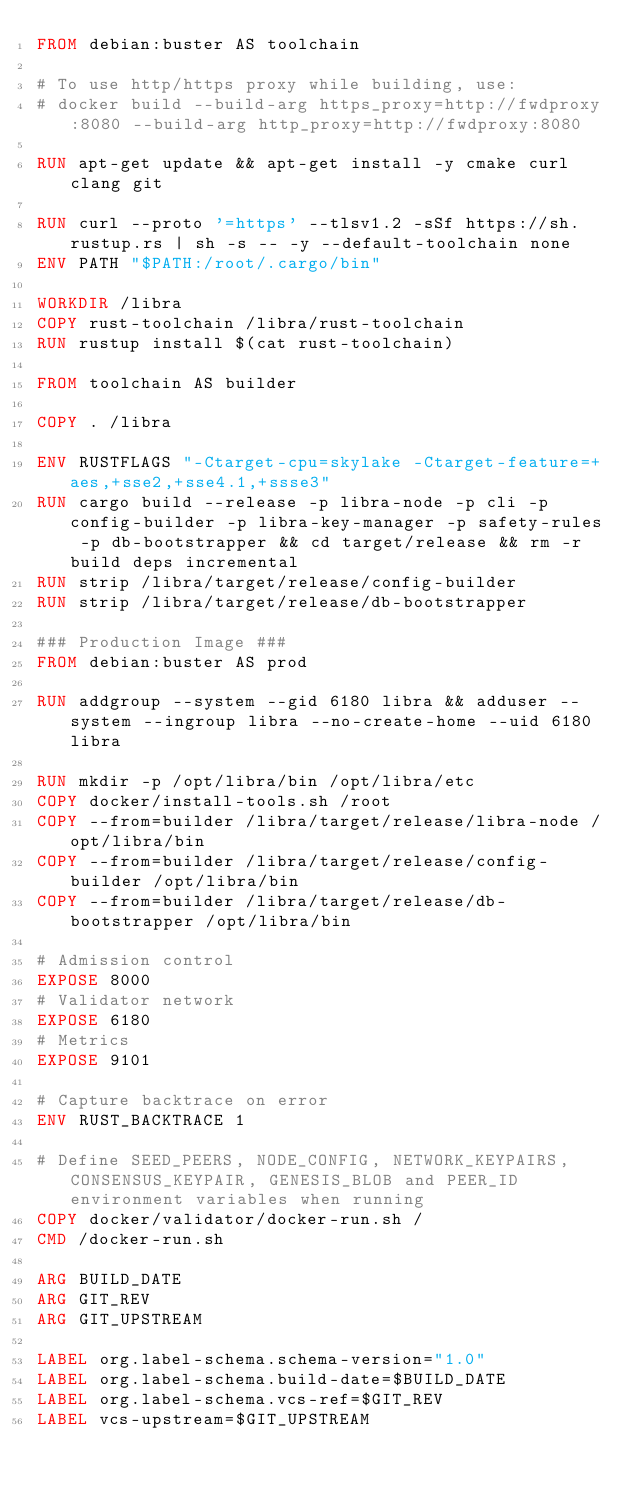<code> <loc_0><loc_0><loc_500><loc_500><_Dockerfile_>FROM debian:buster AS toolchain

# To use http/https proxy while building, use:
# docker build --build-arg https_proxy=http://fwdproxy:8080 --build-arg http_proxy=http://fwdproxy:8080

RUN apt-get update && apt-get install -y cmake curl clang git

RUN curl --proto '=https' --tlsv1.2 -sSf https://sh.rustup.rs | sh -s -- -y --default-toolchain none
ENV PATH "$PATH:/root/.cargo/bin"

WORKDIR /libra
COPY rust-toolchain /libra/rust-toolchain
RUN rustup install $(cat rust-toolchain)

FROM toolchain AS builder

COPY . /libra

ENV RUSTFLAGS "-Ctarget-cpu=skylake -Ctarget-feature=+aes,+sse2,+sse4.1,+ssse3"
RUN cargo build --release -p libra-node -p cli -p config-builder -p libra-key-manager -p safety-rules -p db-bootstrapper && cd target/release && rm -r build deps incremental
RUN strip /libra/target/release/config-builder
RUN strip /libra/target/release/db-bootstrapper

### Production Image ###
FROM debian:buster AS prod

RUN addgroup --system --gid 6180 libra && adduser --system --ingroup libra --no-create-home --uid 6180 libra

RUN mkdir -p /opt/libra/bin /opt/libra/etc
COPY docker/install-tools.sh /root
COPY --from=builder /libra/target/release/libra-node /opt/libra/bin
COPY --from=builder /libra/target/release/config-builder /opt/libra/bin
COPY --from=builder /libra/target/release/db-bootstrapper /opt/libra/bin

# Admission control
EXPOSE 8000
# Validator network
EXPOSE 6180
# Metrics
EXPOSE 9101

# Capture backtrace on error
ENV RUST_BACKTRACE 1

# Define SEED_PEERS, NODE_CONFIG, NETWORK_KEYPAIRS, CONSENSUS_KEYPAIR, GENESIS_BLOB and PEER_ID environment variables when running
COPY docker/validator/docker-run.sh /
CMD /docker-run.sh

ARG BUILD_DATE
ARG GIT_REV
ARG GIT_UPSTREAM

LABEL org.label-schema.schema-version="1.0"
LABEL org.label-schema.build-date=$BUILD_DATE
LABEL org.label-schema.vcs-ref=$GIT_REV
LABEL vcs-upstream=$GIT_UPSTREAM
</code> 